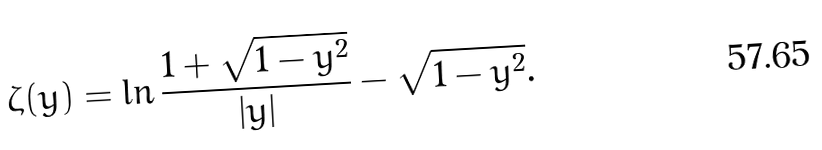Convert formula to latex. <formula><loc_0><loc_0><loc_500><loc_500>\zeta ( y ) = \ln \frac { 1 + \sqrt { 1 - y ^ { 2 } } } { | y | } - \sqrt { 1 - y ^ { 2 } } .</formula> 